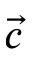<formula> <loc_0><loc_0><loc_500><loc_500>\vec { c }</formula> 